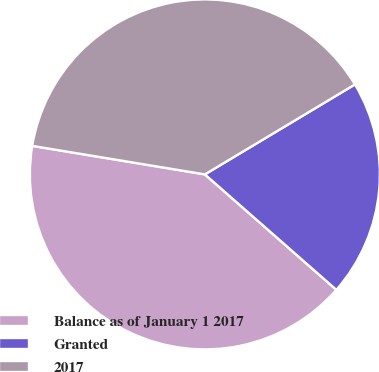Convert chart. <chart><loc_0><loc_0><loc_500><loc_500><pie_chart><fcel>Balance as of January 1 2017<fcel>Granted<fcel>2017<nl><fcel>41.14%<fcel>20.06%<fcel>38.8%<nl></chart> 